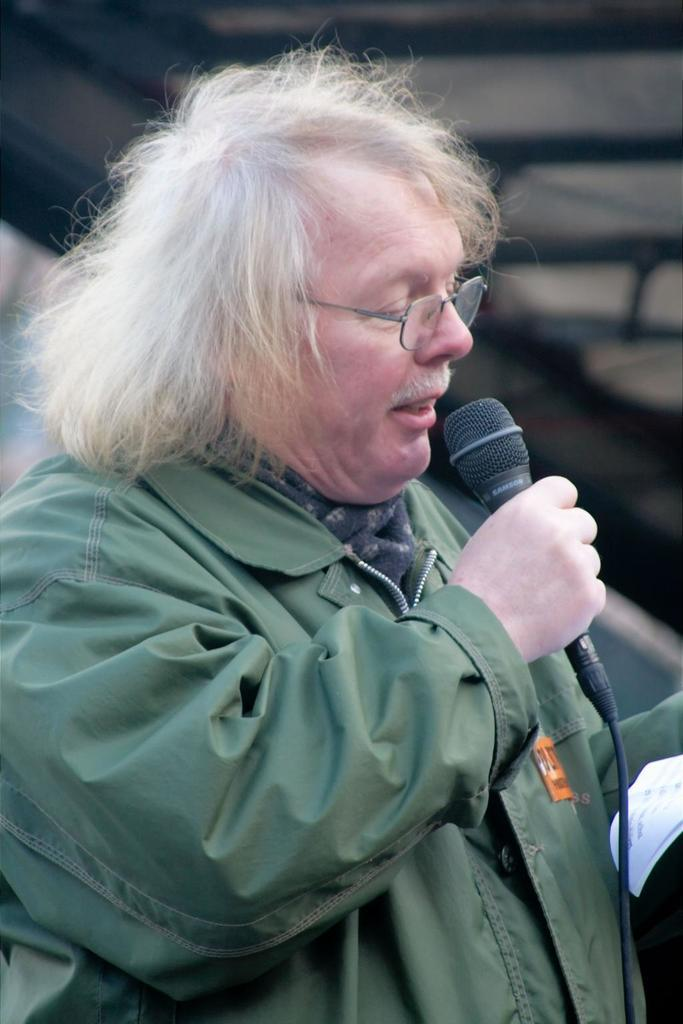What is the person in the image doing? The person is holding a microphone in one hand and a paper in the other hand while talking and looking at the paper. What object is the person holding in their hand? The person is holding a microphone in one hand and a paper in the other hand. What might the person be reading from the paper? The person might be reading notes or a speech from the paper. What type of sweater is the person wearing in the image? There is no sweater visible in the image; the person is not wearing a sweater. Can you tell me how many boats are in the background of the image? There are no boats present in the image; it does not depict a background with boats. 